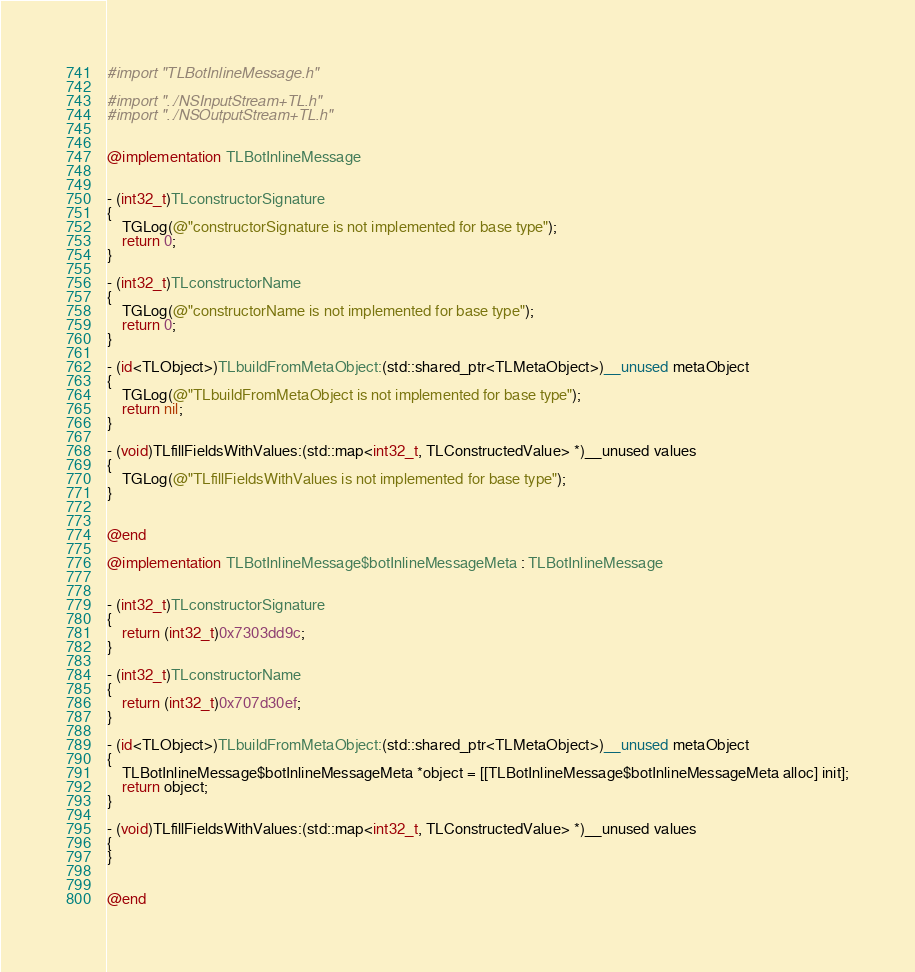Convert code to text. <code><loc_0><loc_0><loc_500><loc_500><_ObjectiveC_>#import "TLBotInlineMessage.h"

#import "../NSInputStream+TL.h"
#import "../NSOutputStream+TL.h"


@implementation TLBotInlineMessage


- (int32_t)TLconstructorSignature
{
    TGLog(@"constructorSignature is not implemented for base type");
    return 0;
}

- (int32_t)TLconstructorName
{
    TGLog(@"constructorName is not implemented for base type");
    return 0;
}

- (id<TLObject>)TLbuildFromMetaObject:(std::shared_ptr<TLMetaObject>)__unused metaObject
{
    TGLog(@"TLbuildFromMetaObject is not implemented for base type");
    return nil;
}

- (void)TLfillFieldsWithValues:(std::map<int32_t, TLConstructedValue> *)__unused values
{
    TGLog(@"TLfillFieldsWithValues is not implemented for base type");
}


@end

@implementation TLBotInlineMessage$botInlineMessageMeta : TLBotInlineMessage


- (int32_t)TLconstructorSignature
{
    return (int32_t)0x7303dd9c;
}

- (int32_t)TLconstructorName
{
    return (int32_t)0x707d30ef;
}

- (id<TLObject>)TLbuildFromMetaObject:(std::shared_ptr<TLMetaObject>)__unused metaObject
{
    TLBotInlineMessage$botInlineMessageMeta *object = [[TLBotInlineMessage$botInlineMessageMeta alloc] init];
    return object;
}

- (void)TLfillFieldsWithValues:(std::map<int32_t, TLConstructedValue> *)__unused values
{
}


@end

</code> 